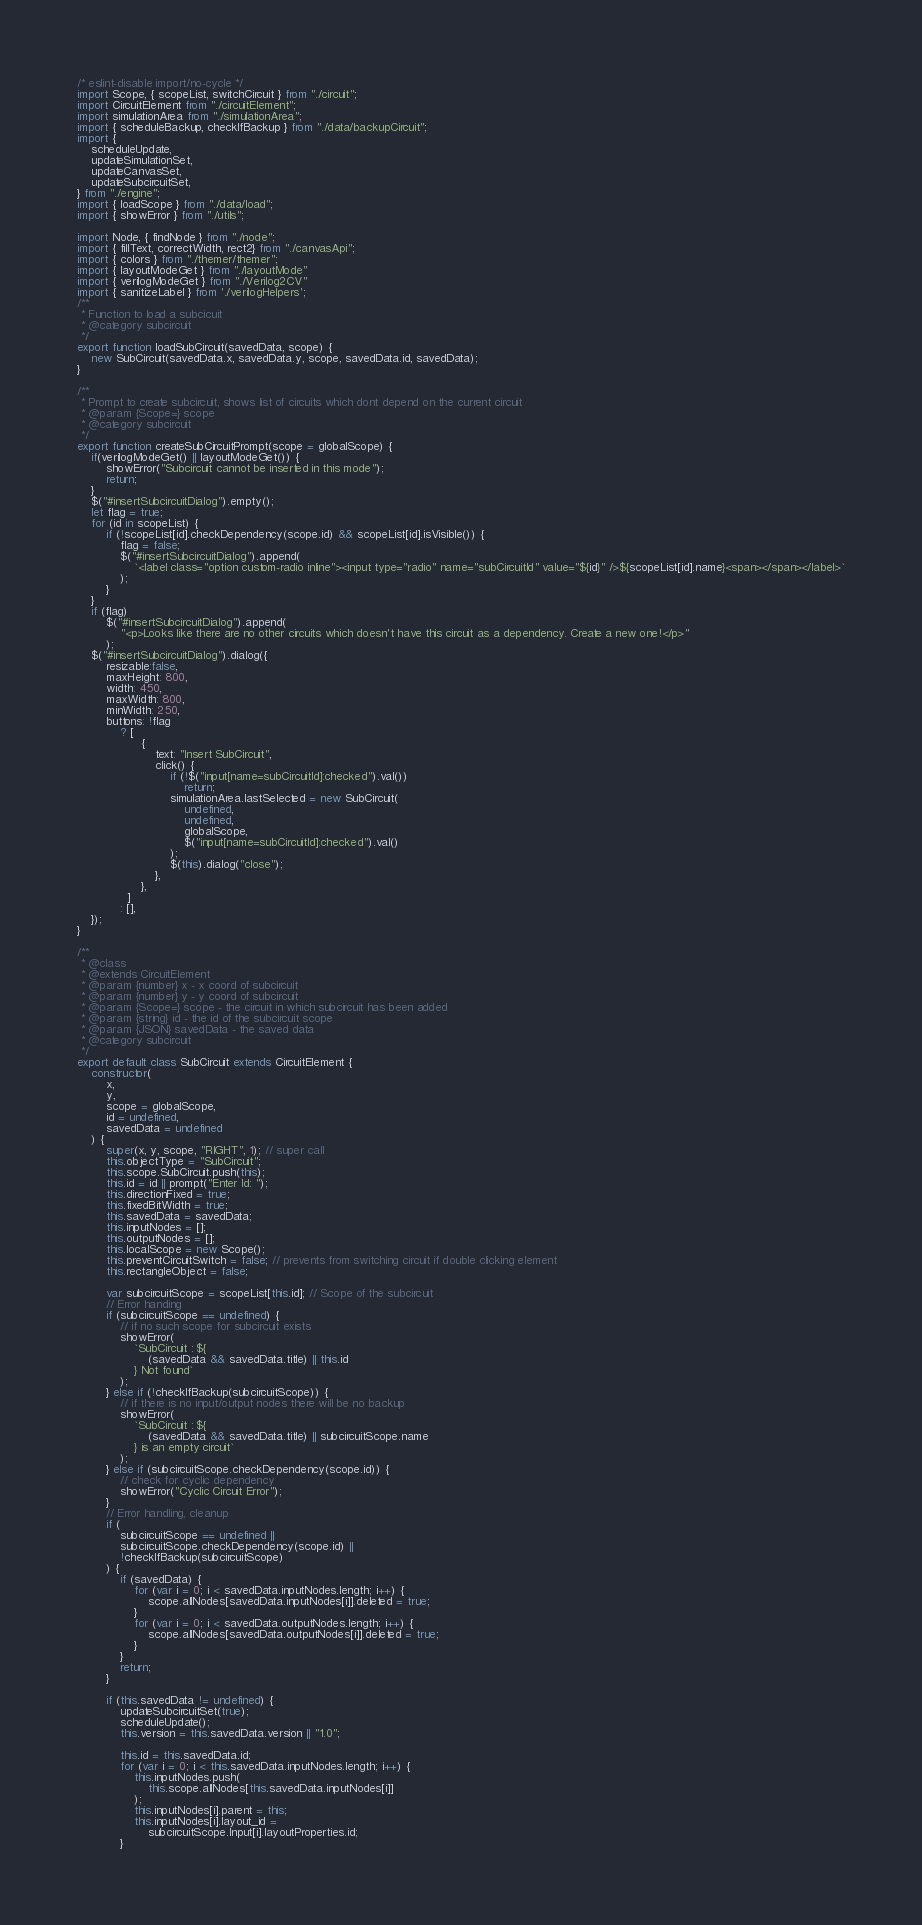Convert code to text. <code><loc_0><loc_0><loc_500><loc_500><_JavaScript_>/* eslint-disable import/no-cycle */
import Scope, { scopeList, switchCircuit } from "./circuit";
import CircuitElement from "./circuitElement";
import simulationArea from "./simulationArea";
import { scheduleBackup, checkIfBackup } from "./data/backupCircuit";
import {
    scheduleUpdate,
    updateSimulationSet,
    updateCanvasSet,
    updateSubcircuitSet,
} from "./engine";
import { loadScope } from "./data/load";
import { showError } from "./utils";

import Node, { findNode } from "./node";
import { fillText, correctWidth, rect2} from "./canvasApi";
import { colors } from "./themer/themer";
import { layoutModeGet } from "./layoutMode"
import { verilogModeGet } from "./Verilog2CV"
import { sanitizeLabel } from './verilogHelpers';
/**
 * Function to load a subcicuit
 * @category subcircuit
 */
export function loadSubCircuit(savedData, scope) {
    new SubCircuit(savedData.x, savedData.y, scope, savedData.id, savedData);
}

/**
 * Prompt to create subcircuit, shows list of circuits which dont depend on the current circuit
 * @param {Scope=} scope
 * @category subcircuit
 */
export function createSubCircuitPrompt(scope = globalScope) {
    if(verilogModeGet() || layoutModeGet()) {
        showError("Subcircuit cannot be inserted in this mode");
        return;
    }
    $("#insertSubcircuitDialog").empty();
    let flag = true;
    for (id in scopeList) {
        if (!scopeList[id].checkDependency(scope.id) && scopeList[id].isVisible()) {
            flag = false;
            $("#insertSubcircuitDialog").append(
                `<label class="option custom-radio inline"><input type="radio" name="subCircuitId" value="${id}" />${scopeList[id].name}<span></span></label>`
            );
        }
    }
    if (flag)
        $("#insertSubcircuitDialog").append(
            "<p>Looks like there are no other circuits which doesn't have this circuit as a dependency. Create a new one!</p>"
        );
    $("#insertSubcircuitDialog").dialog({
        resizable:false,
        maxHeight: 800,
        width: 450,
        maxWidth: 800,
        minWidth: 250,
        buttons: !flag
            ? [
                  {
                      text: "Insert SubCircuit",
                      click() {
                          if (!$("input[name=subCircuitId]:checked").val())
                              return;
                          simulationArea.lastSelected = new SubCircuit(
                              undefined,
                              undefined,
                              globalScope,
                              $("input[name=subCircuitId]:checked").val()
                          );
                          $(this).dialog("close");
                      },
                  },
              ]
            : [],
    });
}

/**
 * @class
 * @extends CircuitElement
 * @param {number} x - x coord of subcircuit
 * @param {number} y - y coord of subcircuit
 * @param {Scope=} scope - the circuit in which subcircuit has been added
 * @param {string} id - the id of the subcircuit scope
 * @param {JSON} savedData - the saved data
 * @category subcircuit
 */
export default class SubCircuit extends CircuitElement {
    constructor(
        x,
        y,
        scope = globalScope,
        id = undefined,
        savedData = undefined
    ) {
        super(x, y, scope, "RIGHT", 1); // super call
        this.objectType = "SubCircuit";
        this.scope.SubCircuit.push(this);
        this.id = id || prompt("Enter Id: ");
        this.directionFixed = true;
        this.fixedBitWidth = true;
        this.savedData = savedData;
        this.inputNodes = [];
        this.outputNodes = [];
        this.localScope = new Scope();
        this.preventCircuitSwitch = false; // prevents from switching circuit if double clicking element
        this.rectangleObject = false;

        var subcircuitScope = scopeList[this.id]; // Scope of the subcircuit
        // Error handing
        if (subcircuitScope == undefined) {
            // if no such scope for subcircuit exists
            showError(
                `SubCircuit : ${
                    (savedData && savedData.title) || this.id
                } Not found`
            );
        } else if (!checkIfBackup(subcircuitScope)) {
            // if there is no input/output nodes there will be no backup
            showError(
                `SubCircuit : ${
                    (savedData && savedData.title) || subcircuitScope.name
                } is an empty circuit`
            );
        } else if (subcircuitScope.checkDependency(scope.id)) {
            // check for cyclic dependency
            showError("Cyclic Circuit Error");
        }
        // Error handling, cleanup
        if (
            subcircuitScope == undefined ||
            subcircuitScope.checkDependency(scope.id) ||
            !checkIfBackup(subcircuitScope)
        ) {
            if (savedData) {
                for (var i = 0; i < savedData.inputNodes.length; i++) {
                    scope.allNodes[savedData.inputNodes[i]].deleted = true;
                }
                for (var i = 0; i < savedData.outputNodes.length; i++) {
                    scope.allNodes[savedData.outputNodes[i]].deleted = true;
                }
            }
            return;
        }

        if (this.savedData != undefined) {
            updateSubcircuitSet(true);
            scheduleUpdate();
            this.version = this.savedData.version || "1.0";

            this.id = this.savedData.id;
            for (var i = 0; i < this.savedData.inputNodes.length; i++) {
                this.inputNodes.push(
                    this.scope.allNodes[this.savedData.inputNodes[i]]
                );
                this.inputNodes[i].parent = this;
                this.inputNodes[i].layout_id =
                    subcircuitScope.Input[i].layoutProperties.id;
            }</code> 